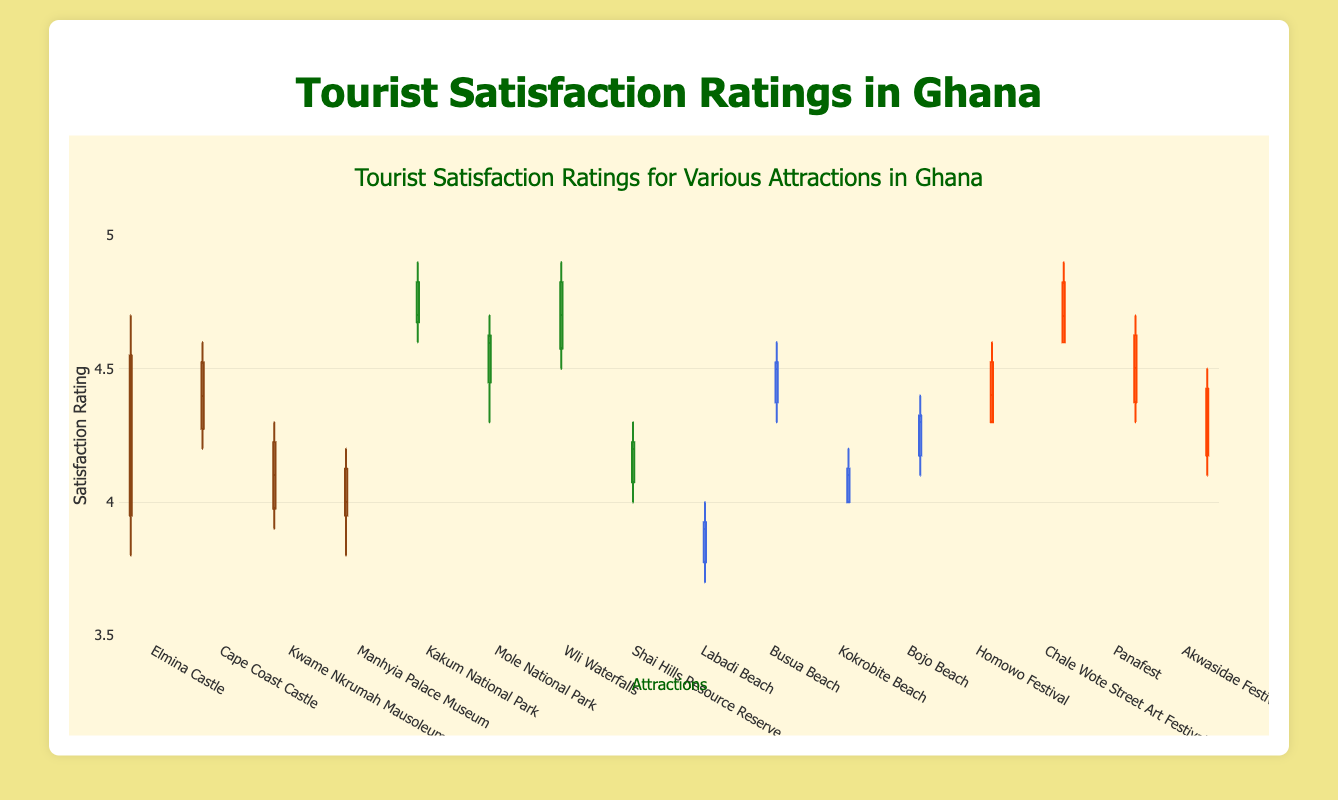Which attraction has the highest median rating among the Historical Sites? To find the highest median rating among the Historical Sites, we need to look at the median lines of the box plots for each historical site and compare them. The one with the highest median line represents the highest median rating.
Answer: Cape Coast Castle What is the range of tourist satisfaction ratings for Labadi Beach? The range is determined by the difference between the highest and lowest values (whiskers) in the box plot for Labadi Beach.
Answer: 3.7 to 4.0 Which type of attraction shows the highest overall satisfaction rating? To determine the highest overall satisfaction, compare the box plots of each type of attraction. The attraction type that has box plots with the highest upper whiskers will represent the highest overall satisfaction.
Answer: Cultural Festivals Are the ratings for Shai Hills Resource Reserve generally higher or lower than those for Wli Waterfalls? By comparing the positions of the box plots for Shai Hills Resource Reserve and Wli Waterfalls, we can see that the entire range (box and whiskers) of Wli Waterfalls is higher than that of Shai Hills Resource Reserve.
Answer: Lower What is the median satisfaction rating for the Chale Wote Street Art Festival? Check the middle line of the box plot for the Chale Wote Street Art Festival to find the median.
Answer: 4.7 Which Beach has the smallest interquartile range (IQR) for ratings? The IQR is determined by the length of the box in each box plot. The shortest box for the beach category represents the smallest IQR.
Answer: Labadi Beach How do the median ratings of Natural Parks compare to those of Historical Sites? Compare the median lines of the box plots under Natural Parks with those under Historical Sites. Generally, median ratings for Natural Parks are higher.
Answer: Natural Parks are higher Which Cultural Festival shows the least variability in ratings? Variability is shown by the spread of the box plot, with the least variability indicated by the narrowest box.
Answer: Akwasidae Festival What are the upper and lower quartiles for Elmina Castle? The upper quartile (Q3) is the top of the box, and the lower quartile (Q1) is the bottom of the box in Elmina Castle’s box plot.
Answer: Q1: 4.0, Q3: 4.5 Which attraction has the lowest minimum satisfaction rating? Identify the attraction with the lowest point (whisker) on the box plots. This represents the lowest minimum satisfaction rating.
Answer: Labadi Beach 